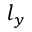Convert formula to latex. <formula><loc_0><loc_0><loc_500><loc_500>l _ { y }</formula> 